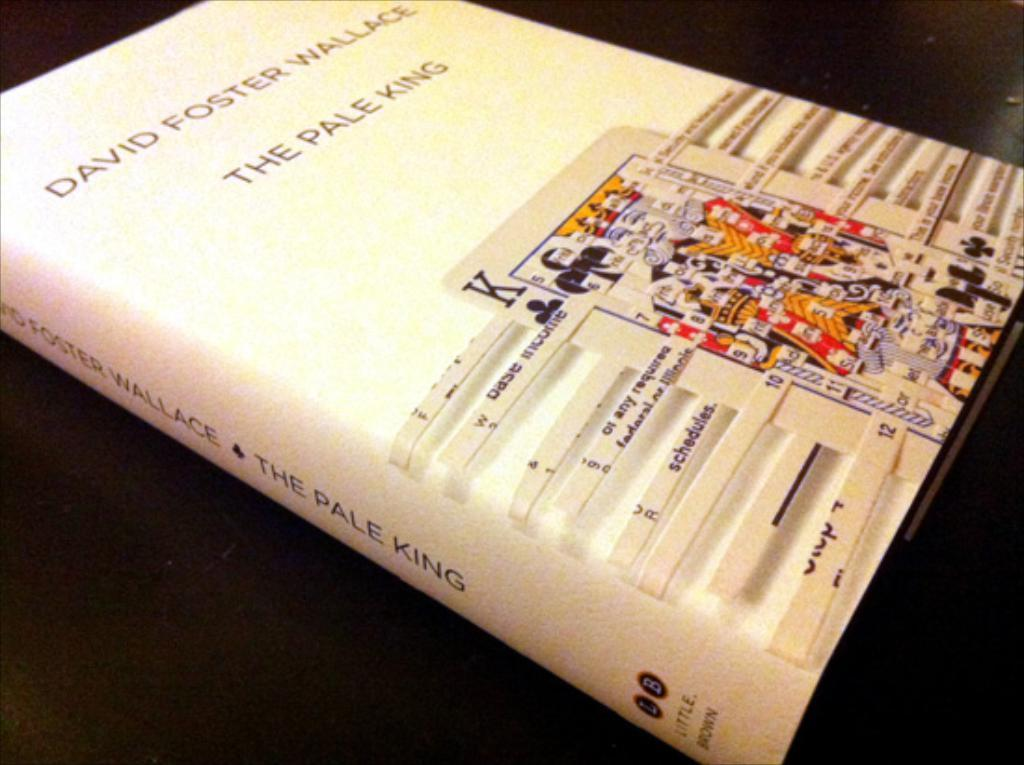<image>
Render a clear and concise summary of the photo. David Foster Wallace's book entitled The Pale King 